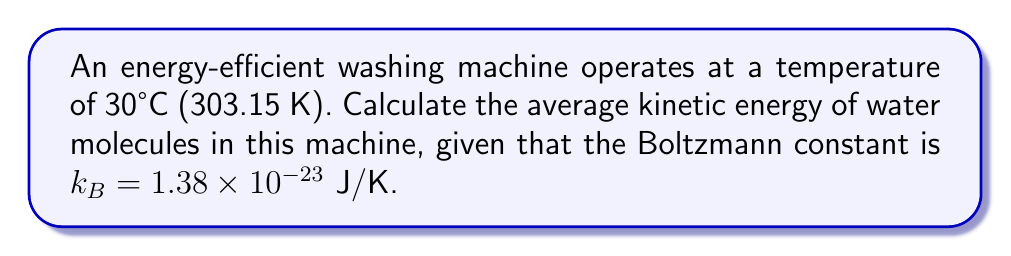Can you answer this question? To solve this problem, we'll use the principle of equipartition of energy from statistical mechanics. For water molecules, which are non-linear molecules with 3 translational and 3 rotational degrees of freedom, we follow these steps:

1. The average kinetic energy per degree of freedom is given by:
   $$\langle E \rangle = \frac{1}{2}k_BT$$

2. For water molecules, we consider 6 degrees of freedom (3 translational + 3 rotational):
   $$\langle E_{total} \rangle = 6 \times \frac{1}{2}k_BT = 3k_BT$$

3. Substitute the given values:
   $T = 303.15$ K
   $k_B = 1.38 \times 10^{-23}$ J/K

4. Calculate the average kinetic energy:
   $$\langle E_{total} \rangle = 3 \times (1.38 \times 10^{-23} \text{ J/K}) \times (303.15 \text{ K})$$
   $$\langle E_{total} \rangle = 1.25 \times 10^{-20} \text{ J}$$

This result represents the average kinetic energy per water molecule in the energy-efficient washing machine.
Answer: $1.25 \times 10^{-20}$ J 